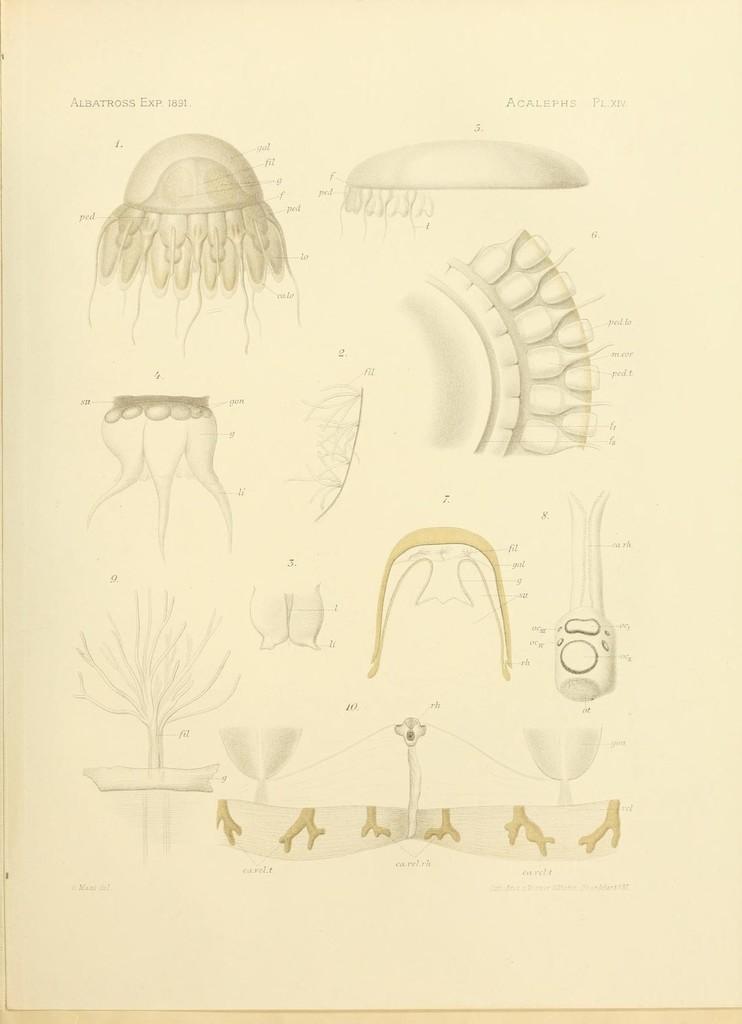Please provide a concise description of this image. In this image I can see few pictures on the cream color paper and I can see something written on it. 